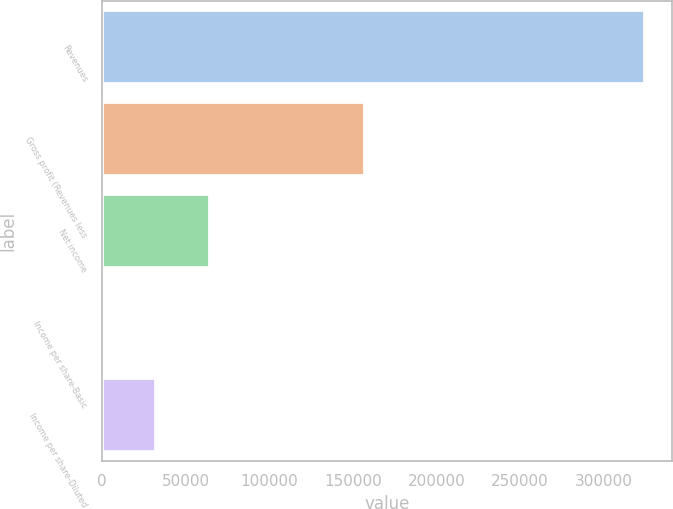<chart> <loc_0><loc_0><loc_500><loc_500><bar_chart><fcel>Revenues<fcel>Gross profit (Revenues less<fcel>Net income<fcel>Income per share-Basic<fcel>Income per share-Diluted<nl><fcel>324707<fcel>157350<fcel>64941.6<fcel>0.19<fcel>32470.9<nl></chart> 